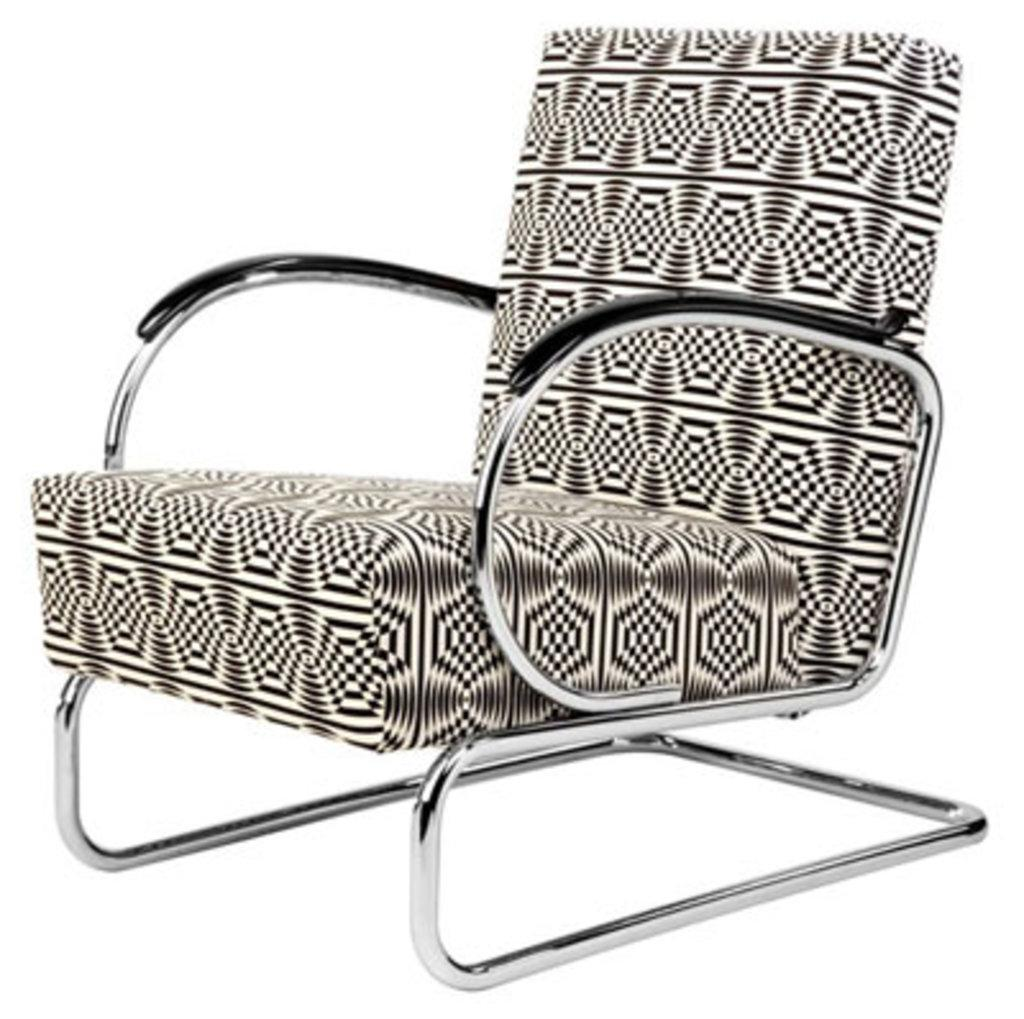What type of furniture is present in the image? There is a chair in the image. What is the chair using to cause a storm in the image? There is no indication in the image that the chair is causing a storm or using any object to do so. 